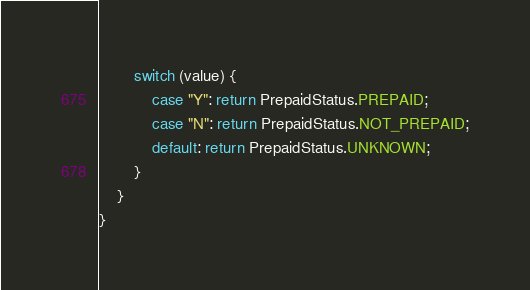Convert code to text. <code><loc_0><loc_0><loc_500><loc_500><_Java_>
        switch (value) {
            case "Y": return PrepaidStatus.PREPAID;
            case "N": return PrepaidStatus.NOT_PREPAID;
            default: return PrepaidStatus.UNKNOWN;
        }
    }
}
</code> 